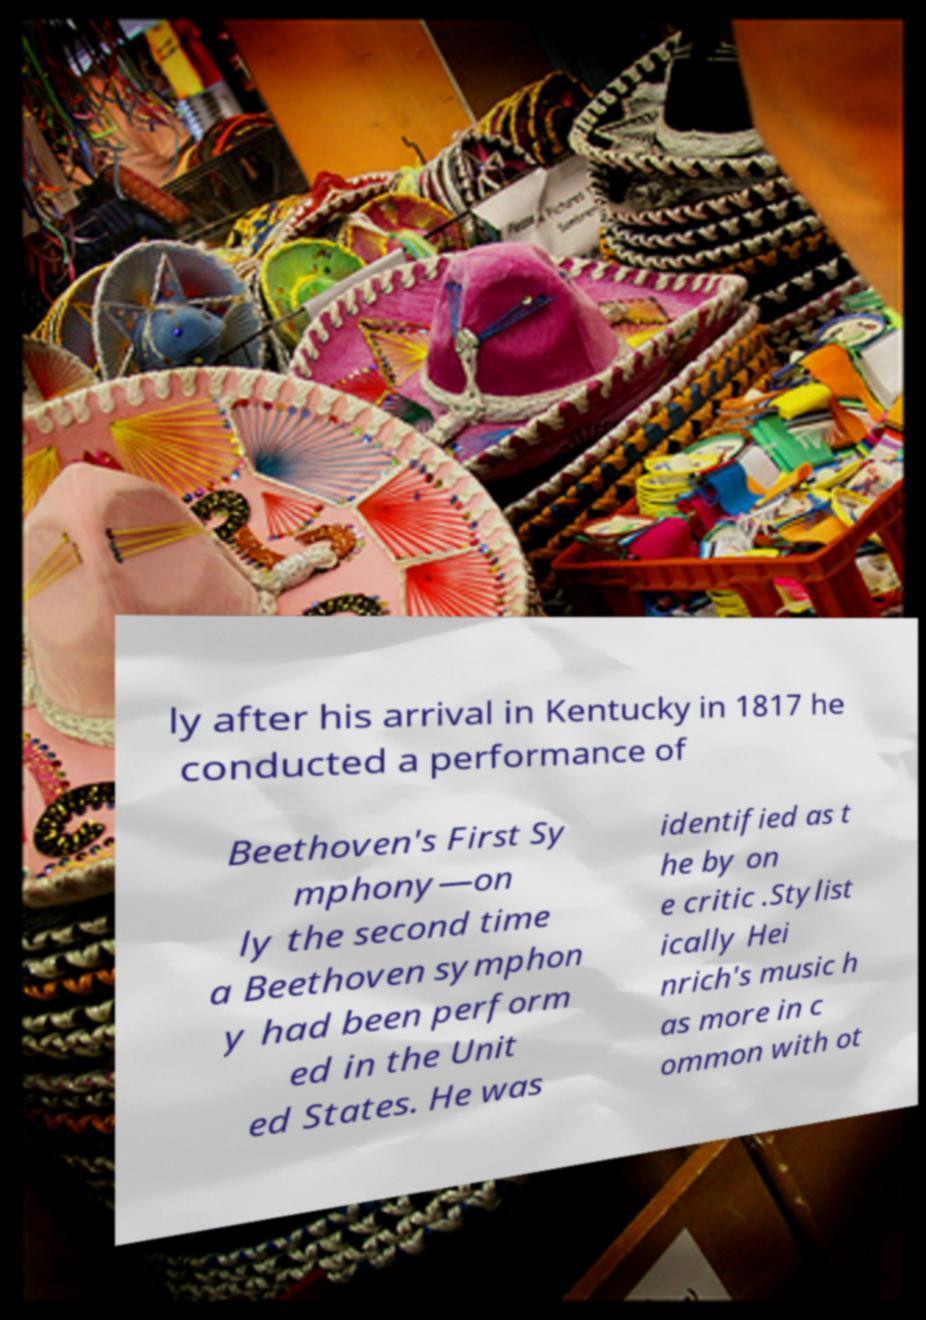There's text embedded in this image that I need extracted. Can you transcribe it verbatim? ly after his arrival in Kentucky in 1817 he conducted a performance of Beethoven's First Sy mphony—on ly the second time a Beethoven symphon y had been perform ed in the Unit ed States. He was identified as t he by on e critic .Stylist ically Hei nrich's music h as more in c ommon with ot 